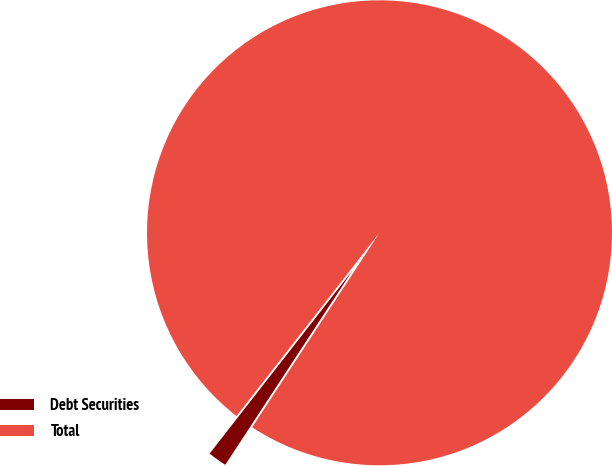<chart> <loc_0><loc_0><loc_500><loc_500><pie_chart><fcel>Debt Securities<fcel>Total<nl><fcel>1.32%<fcel>98.68%<nl></chart> 